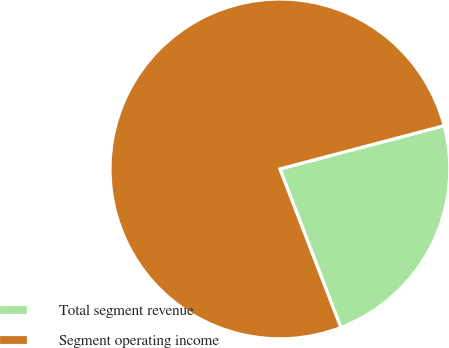Convert chart to OTSL. <chart><loc_0><loc_0><loc_500><loc_500><pie_chart><fcel>Total segment revenue<fcel>Segment operating income<nl><fcel>23.26%<fcel>76.74%<nl></chart> 